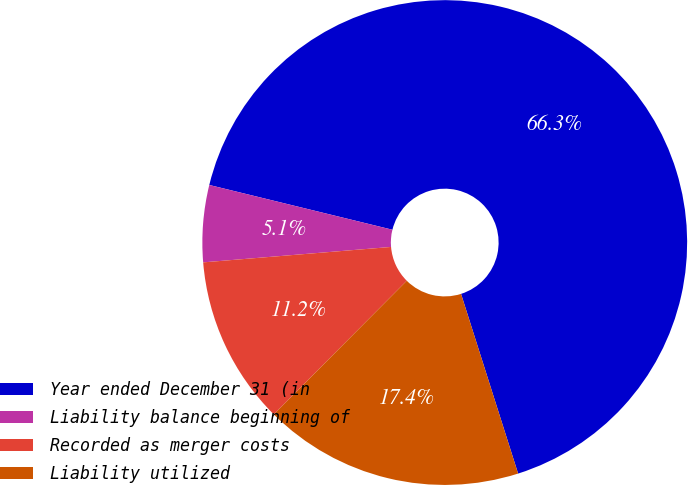Convert chart to OTSL. <chart><loc_0><loc_0><loc_500><loc_500><pie_chart><fcel>Year ended December 31 (in<fcel>Liability balance beginning of<fcel>Recorded as merger costs<fcel>Liability utilized<nl><fcel>66.29%<fcel>5.12%<fcel>11.24%<fcel>17.35%<nl></chart> 